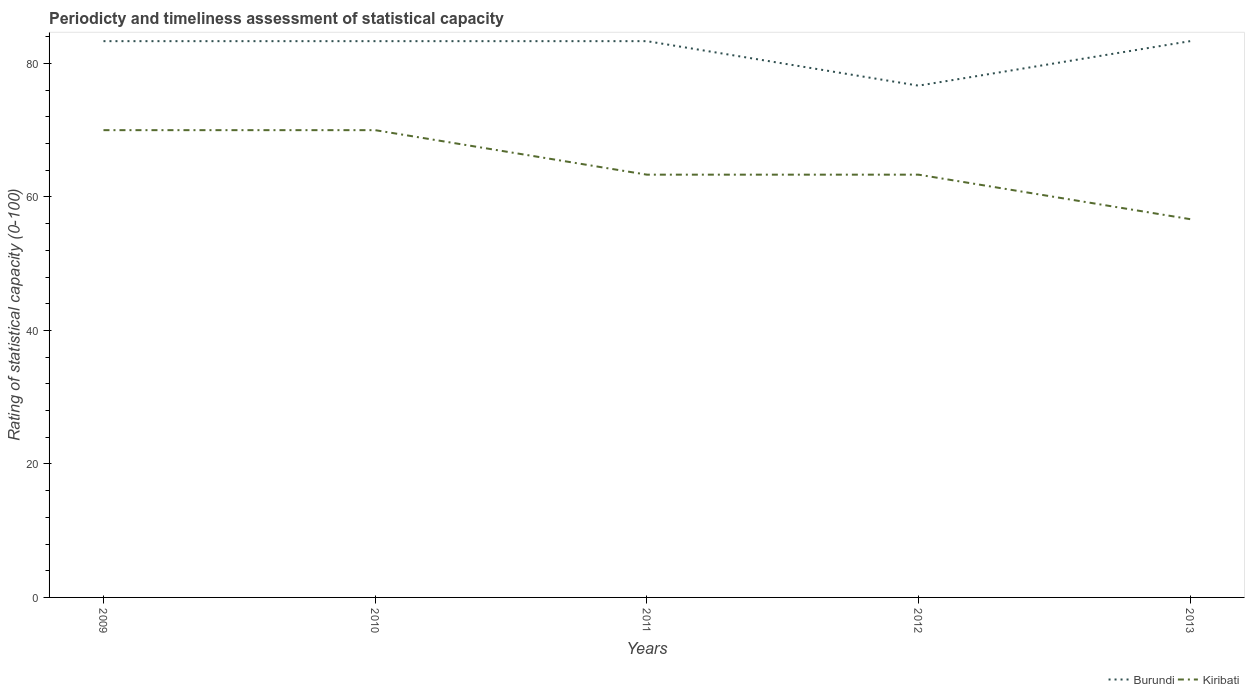Does the line corresponding to Kiribati intersect with the line corresponding to Burundi?
Offer a terse response. No. Across all years, what is the maximum rating of statistical capacity in Kiribati?
Your answer should be compact. 56.67. In which year was the rating of statistical capacity in Kiribati maximum?
Provide a short and direct response. 2013. What is the total rating of statistical capacity in Kiribati in the graph?
Offer a terse response. 13.33. What is the difference between the highest and the second highest rating of statistical capacity in Kiribati?
Your response must be concise. 13.33. What is the difference between the highest and the lowest rating of statistical capacity in Burundi?
Keep it short and to the point. 4. Is the rating of statistical capacity in Kiribati strictly greater than the rating of statistical capacity in Burundi over the years?
Offer a terse response. Yes. How many lines are there?
Offer a very short reply. 2. How many years are there in the graph?
Make the answer very short. 5. What is the difference between two consecutive major ticks on the Y-axis?
Your answer should be compact. 20. Does the graph contain any zero values?
Offer a terse response. No. How many legend labels are there?
Keep it short and to the point. 2. What is the title of the graph?
Ensure brevity in your answer.  Periodicty and timeliness assessment of statistical capacity. Does "Least developed countries" appear as one of the legend labels in the graph?
Ensure brevity in your answer.  No. What is the label or title of the X-axis?
Offer a terse response. Years. What is the label or title of the Y-axis?
Keep it short and to the point. Rating of statistical capacity (0-100). What is the Rating of statistical capacity (0-100) of Burundi in 2009?
Keep it short and to the point. 83.33. What is the Rating of statistical capacity (0-100) in Burundi in 2010?
Provide a succinct answer. 83.33. What is the Rating of statistical capacity (0-100) in Burundi in 2011?
Your answer should be compact. 83.33. What is the Rating of statistical capacity (0-100) of Kiribati in 2011?
Keep it short and to the point. 63.33. What is the Rating of statistical capacity (0-100) of Burundi in 2012?
Provide a succinct answer. 76.67. What is the Rating of statistical capacity (0-100) in Kiribati in 2012?
Your response must be concise. 63.33. What is the Rating of statistical capacity (0-100) of Burundi in 2013?
Provide a short and direct response. 83.33. What is the Rating of statistical capacity (0-100) of Kiribati in 2013?
Your answer should be very brief. 56.67. Across all years, what is the maximum Rating of statistical capacity (0-100) in Burundi?
Keep it short and to the point. 83.33. Across all years, what is the minimum Rating of statistical capacity (0-100) in Burundi?
Your answer should be very brief. 76.67. Across all years, what is the minimum Rating of statistical capacity (0-100) of Kiribati?
Ensure brevity in your answer.  56.67. What is the total Rating of statistical capacity (0-100) of Burundi in the graph?
Provide a succinct answer. 410. What is the total Rating of statistical capacity (0-100) in Kiribati in the graph?
Your response must be concise. 323.33. What is the difference between the Rating of statistical capacity (0-100) in Burundi in 2009 and that in 2010?
Offer a very short reply. 0. What is the difference between the Rating of statistical capacity (0-100) of Kiribati in 2009 and that in 2010?
Your response must be concise. 0. What is the difference between the Rating of statistical capacity (0-100) in Kiribati in 2009 and that in 2012?
Ensure brevity in your answer.  6.67. What is the difference between the Rating of statistical capacity (0-100) of Kiribati in 2009 and that in 2013?
Offer a terse response. 13.33. What is the difference between the Rating of statistical capacity (0-100) in Burundi in 2010 and that in 2011?
Offer a very short reply. 0. What is the difference between the Rating of statistical capacity (0-100) in Kiribati in 2010 and that in 2012?
Provide a succinct answer. 6.67. What is the difference between the Rating of statistical capacity (0-100) of Kiribati in 2010 and that in 2013?
Your answer should be compact. 13.33. What is the difference between the Rating of statistical capacity (0-100) in Kiribati in 2011 and that in 2012?
Give a very brief answer. 0. What is the difference between the Rating of statistical capacity (0-100) in Burundi in 2012 and that in 2013?
Your response must be concise. -6.67. What is the difference between the Rating of statistical capacity (0-100) in Kiribati in 2012 and that in 2013?
Make the answer very short. 6.67. What is the difference between the Rating of statistical capacity (0-100) of Burundi in 2009 and the Rating of statistical capacity (0-100) of Kiribati in 2010?
Your answer should be very brief. 13.33. What is the difference between the Rating of statistical capacity (0-100) of Burundi in 2009 and the Rating of statistical capacity (0-100) of Kiribati in 2011?
Make the answer very short. 20. What is the difference between the Rating of statistical capacity (0-100) of Burundi in 2009 and the Rating of statistical capacity (0-100) of Kiribati in 2013?
Offer a very short reply. 26.67. What is the difference between the Rating of statistical capacity (0-100) in Burundi in 2010 and the Rating of statistical capacity (0-100) in Kiribati in 2012?
Keep it short and to the point. 20. What is the difference between the Rating of statistical capacity (0-100) of Burundi in 2010 and the Rating of statistical capacity (0-100) of Kiribati in 2013?
Provide a succinct answer. 26.67. What is the difference between the Rating of statistical capacity (0-100) of Burundi in 2011 and the Rating of statistical capacity (0-100) of Kiribati in 2013?
Your answer should be compact. 26.67. What is the difference between the Rating of statistical capacity (0-100) in Burundi in 2012 and the Rating of statistical capacity (0-100) in Kiribati in 2013?
Give a very brief answer. 20. What is the average Rating of statistical capacity (0-100) in Burundi per year?
Offer a terse response. 82. What is the average Rating of statistical capacity (0-100) of Kiribati per year?
Your answer should be compact. 64.67. In the year 2009, what is the difference between the Rating of statistical capacity (0-100) in Burundi and Rating of statistical capacity (0-100) in Kiribati?
Provide a succinct answer. 13.33. In the year 2010, what is the difference between the Rating of statistical capacity (0-100) in Burundi and Rating of statistical capacity (0-100) in Kiribati?
Keep it short and to the point. 13.33. In the year 2011, what is the difference between the Rating of statistical capacity (0-100) of Burundi and Rating of statistical capacity (0-100) of Kiribati?
Your answer should be very brief. 20. In the year 2012, what is the difference between the Rating of statistical capacity (0-100) in Burundi and Rating of statistical capacity (0-100) in Kiribati?
Your answer should be compact. 13.33. In the year 2013, what is the difference between the Rating of statistical capacity (0-100) in Burundi and Rating of statistical capacity (0-100) in Kiribati?
Your answer should be very brief. 26.67. What is the ratio of the Rating of statistical capacity (0-100) in Burundi in 2009 to that in 2010?
Provide a succinct answer. 1. What is the ratio of the Rating of statistical capacity (0-100) in Kiribati in 2009 to that in 2011?
Provide a succinct answer. 1.11. What is the ratio of the Rating of statistical capacity (0-100) in Burundi in 2009 to that in 2012?
Offer a terse response. 1.09. What is the ratio of the Rating of statistical capacity (0-100) of Kiribati in 2009 to that in 2012?
Provide a short and direct response. 1.11. What is the ratio of the Rating of statistical capacity (0-100) of Burundi in 2009 to that in 2013?
Provide a short and direct response. 1. What is the ratio of the Rating of statistical capacity (0-100) in Kiribati in 2009 to that in 2013?
Provide a short and direct response. 1.24. What is the ratio of the Rating of statistical capacity (0-100) in Burundi in 2010 to that in 2011?
Your answer should be compact. 1. What is the ratio of the Rating of statistical capacity (0-100) in Kiribati in 2010 to that in 2011?
Keep it short and to the point. 1.11. What is the ratio of the Rating of statistical capacity (0-100) in Burundi in 2010 to that in 2012?
Your response must be concise. 1.09. What is the ratio of the Rating of statistical capacity (0-100) in Kiribati in 2010 to that in 2012?
Your response must be concise. 1.11. What is the ratio of the Rating of statistical capacity (0-100) of Kiribati in 2010 to that in 2013?
Provide a short and direct response. 1.24. What is the ratio of the Rating of statistical capacity (0-100) of Burundi in 2011 to that in 2012?
Your response must be concise. 1.09. What is the ratio of the Rating of statistical capacity (0-100) of Kiribati in 2011 to that in 2013?
Your response must be concise. 1.12. What is the ratio of the Rating of statistical capacity (0-100) in Burundi in 2012 to that in 2013?
Your answer should be compact. 0.92. What is the ratio of the Rating of statistical capacity (0-100) in Kiribati in 2012 to that in 2013?
Ensure brevity in your answer.  1.12. What is the difference between the highest and the second highest Rating of statistical capacity (0-100) in Burundi?
Give a very brief answer. 0. What is the difference between the highest and the lowest Rating of statistical capacity (0-100) of Burundi?
Provide a short and direct response. 6.67. What is the difference between the highest and the lowest Rating of statistical capacity (0-100) of Kiribati?
Your response must be concise. 13.33. 